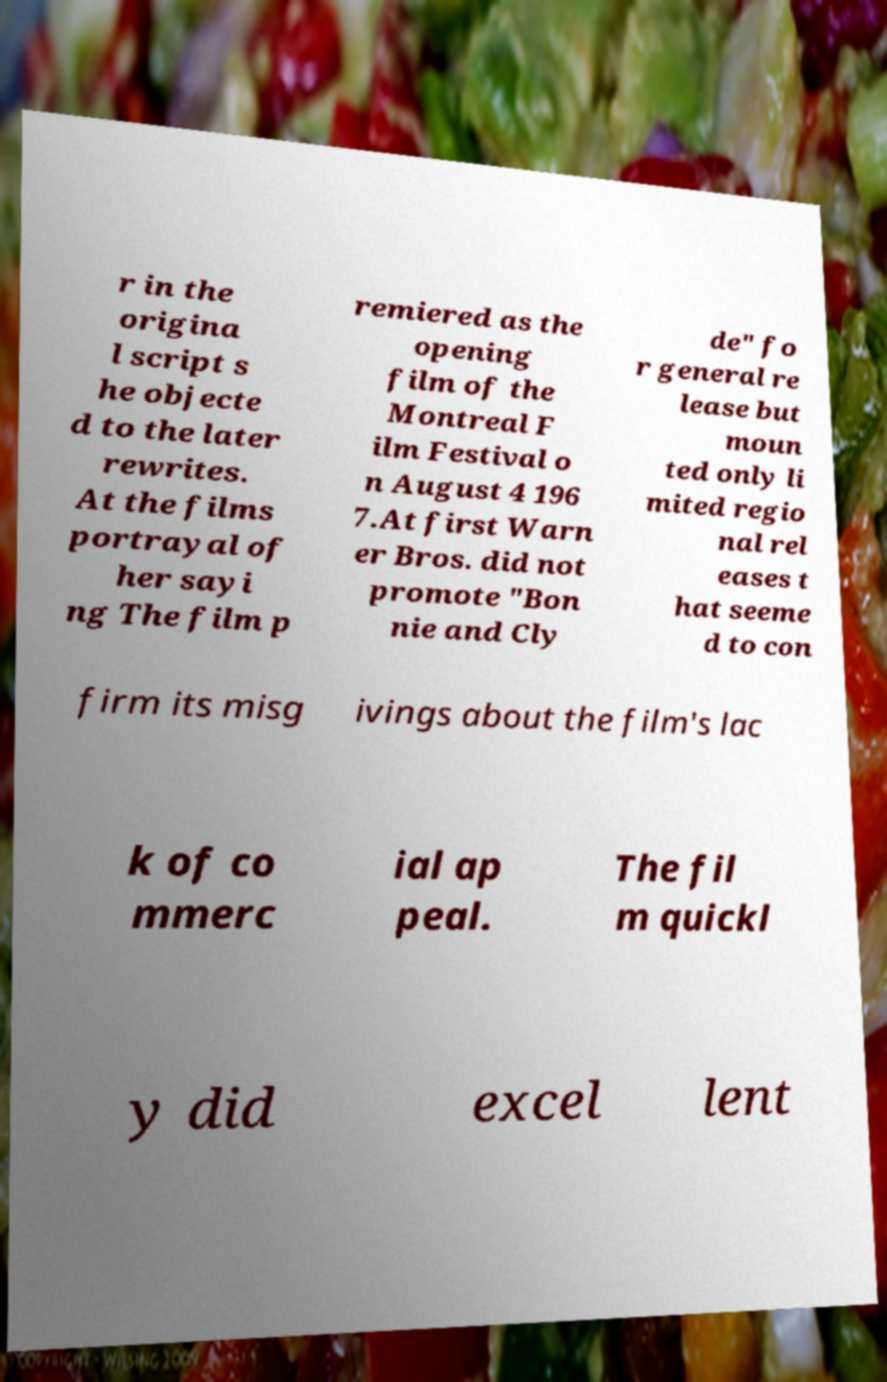There's text embedded in this image that I need extracted. Can you transcribe it verbatim? r in the origina l script s he objecte d to the later rewrites. At the films portrayal of her sayi ng The film p remiered as the opening film of the Montreal F ilm Festival o n August 4 196 7.At first Warn er Bros. did not promote "Bon nie and Cly de" fo r general re lease but moun ted only li mited regio nal rel eases t hat seeme d to con firm its misg ivings about the film's lac k of co mmerc ial ap peal. The fil m quickl y did excel lent 